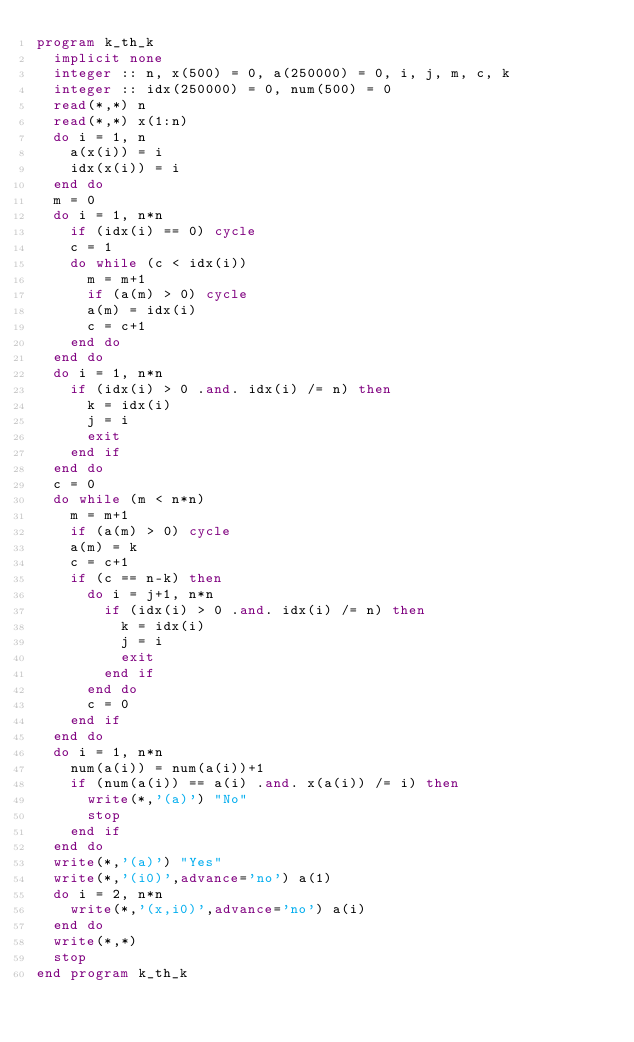Convert code to text. <code><loc_0><loc_0><loc_500><loc_500><_FORTRAN_>program k_th_k
  implicit none
  integer :: n, x(500) = 0, a(250000) = 0, i, j, m, c, k
  integer :: idx(250000) = 0, num(500) = 0
  read(*,*) n
  read(*,*) x(1:n)
  do i = 1, n
    a(x(i)) = i
    idx(x(i)) = i
  end do
  m = 0
  do i = 1, n*n
    if (idx(i) == 0) cycle
    c = 1
    do while (c < idx(i))
      m = m+1
      if (a(m) > 0) cycle
      a(m) = idx(i)
      c = c+1
    end do
  end do
  do i = 1, n*n
    if (idx(i) > 0 .and. idx(i) /= n) then
      k = idx(i)
      j = i
      exit
    end if
  end do
  c = 0
  do while (m < n*n)
    m = m+1
    if (a(m) > 0) cycle
    a(m) = k
    c = c+1
    if (c == n-k) then
      do i = j+1, n*n
        if (idx(i) > 0 .and. idx(i) /= n) then
          k = idx(i)
          j = i
          exit
        end if
      end do
      c = 0
    end if
  end do
  do i = 1, n*n
    num(a(i)) = num(a(i))+1
    if (num(a(i)) == a(i) .and. x(a(i)) /= i) then
      write(*,'(a)') "No"
      stop
    end if
  end do
  write(*,'(a)') "Yes"
  write(*,'(i0)',advance='no') a(1)
  do i = 2, n*n
    write(*,'(x,i0)',advance='no') a(i)
  end do
  write(*,*)
  stop
end program k_th_k</code> 